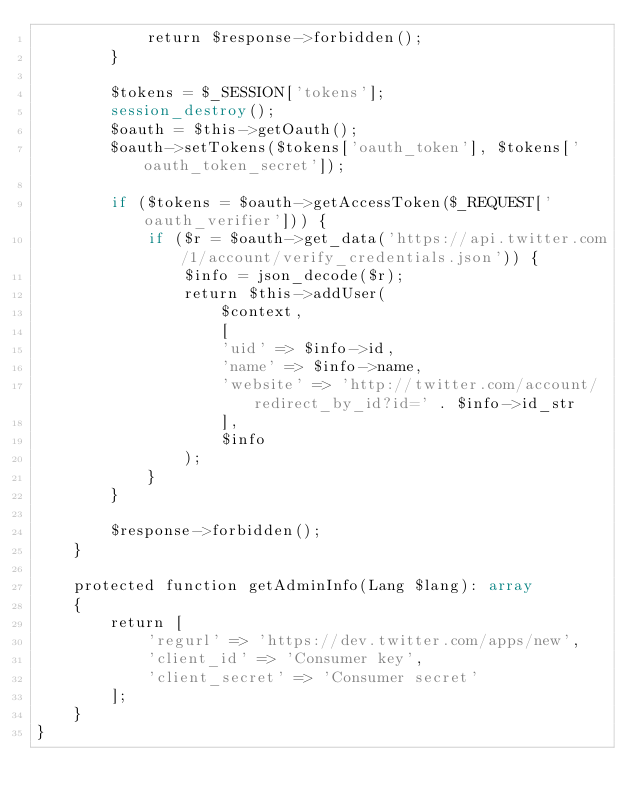Convert code to text. <code><loc_0><loc_0><loc_500><loc_500><_PHP_>            return $response->forbidden();
        }

        $tokens = $_SESSION['tokens'];
        session_destroy();
        $oauth = $this->getOauth();
        $oauth->setTokens($tokens['oauth_token'], $tokens['oauth_token_secret']);

        if ($tokens = $oauth->getAccessToken($_REQUEST['oauth_verifier'])) {
            if ($r = $oauth->get_data('https://api.twitter.com/1/account/verify_credentials.json')) {
                $info = json_decode($r);
                return $this->addUser(
                    $context,
                    [
                    'uid' => $info->id,
                    'name' => $info->name,
                    'website' => 'http://twitter.com/account/redirect_by_id?id=' . $info->id_str
                    ],
                    $info
                );
            }
        }

        $response->forbidden();
    }

    protected function getAdminInfo(Lang $lang): array
    {
        return [
            'regurl' => 'https://dev.twitter.com/apps/new',
            'client_id' => 'Consumer key',
            'client_secret' => 'Consumer secret'
        ];
    }
}
</code> 